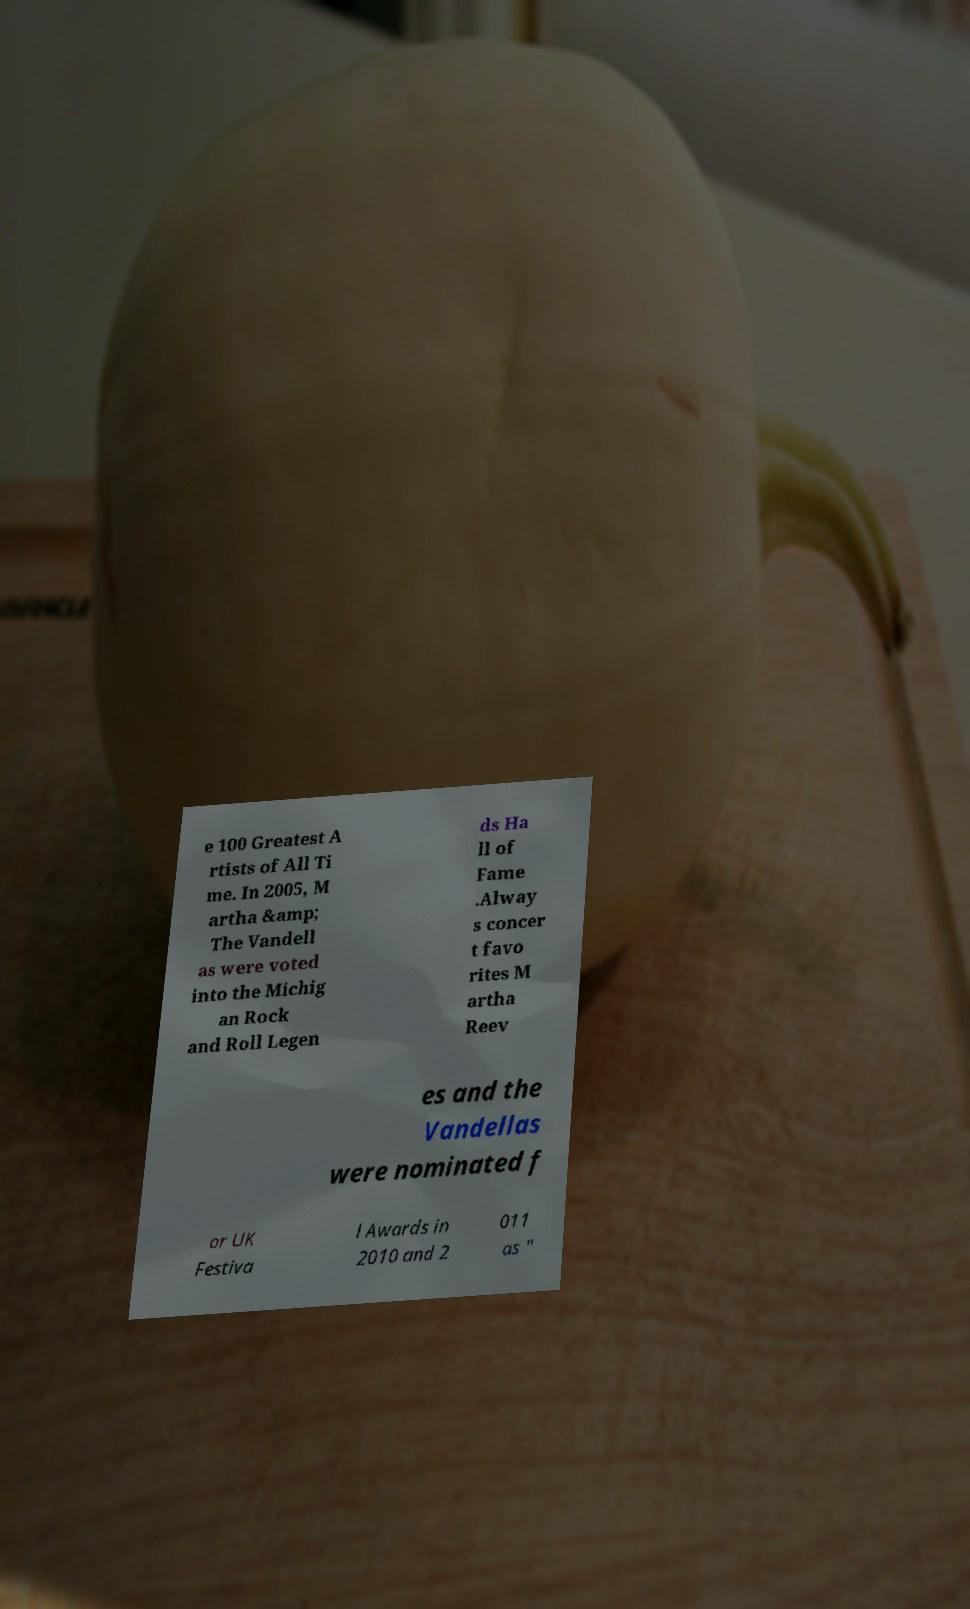For documentation purposes, I need the text within this image transcribed. Could you provide that? e 100 Greatest A rtists of All Ti me. In 2005, M artha &amp; The Vandell as were voted into the Michig an Rock and Roll Legen ds Ha ll of Fame .Alway s concer t favo rites M artha Reev es and the Vandellas were nominated f or UK Festiva l Awards in 2010 and 2 011 as " 